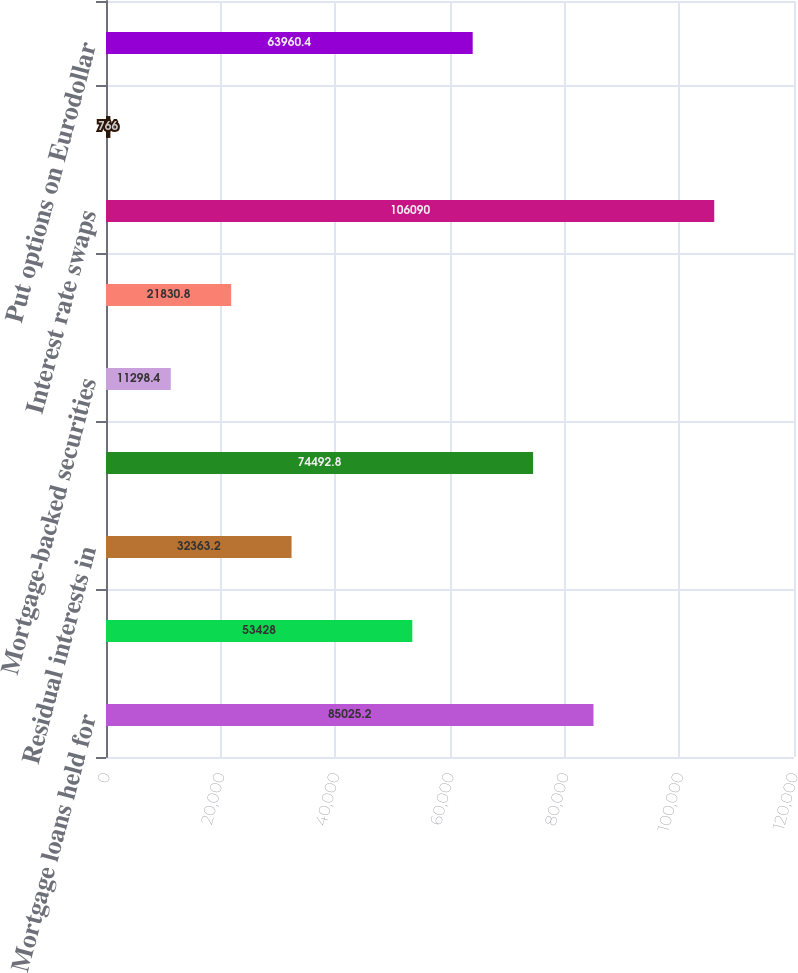Convert chart. <chart><loc_0><loc_0><loc_500><loc_500><bar_chart><fcel>Mortgage loans held for<fcel>Mortgage loans held for sale<fcel>Residual interests in<fcel>Beneficial interest in Trusts<fcel>Mortgage-backed securities<fcel>Fixed-income -trading (net)<fcel>Interest rate swaps<fcel>Investments at captive<fcel>Put options on Eurodollar<nl><fcel>85025.2<fcel>53428<fcel>32363.2<fcel>74492.8<fcel>11298.4<fcel>21830.8<fcel>106090<fcel>766<fcel>63960.4<nl></chart> 